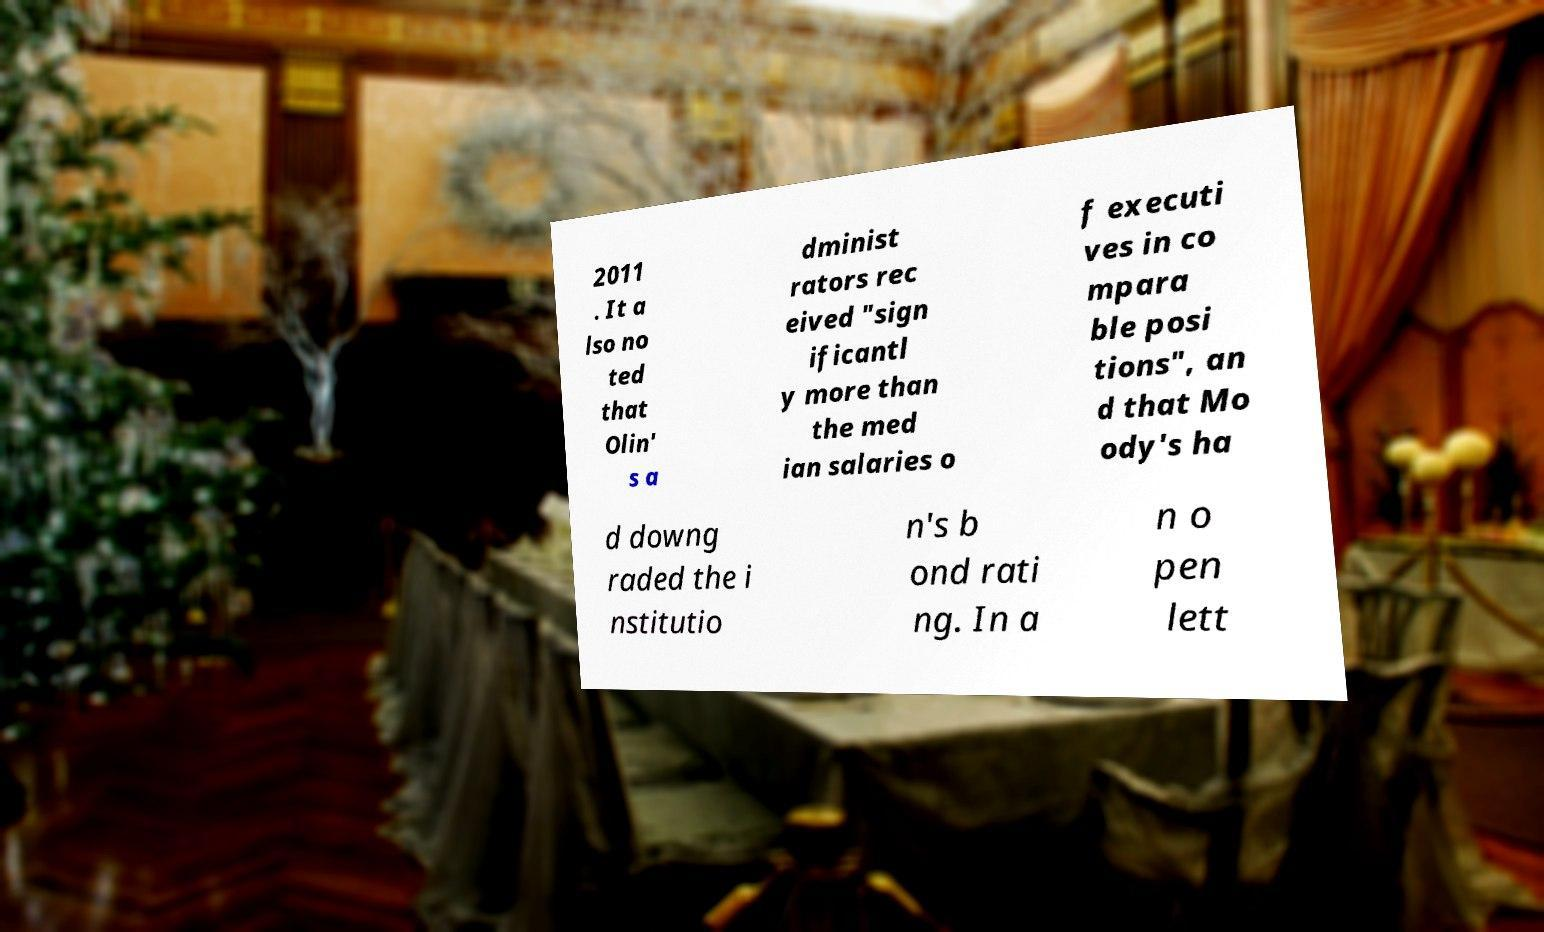Could you assist in decoding the text presented in this image and type it out clearly? 2011 . It a lso no ted that Olin' s a dminist rators rec eived "sign ificantl y more than the med ian salaries o f executi ves in co mpara ble posi tions", an d that Mo ody's ha d downg raded the i nstitutio n's b ond rati ng. In a n o pen lett 